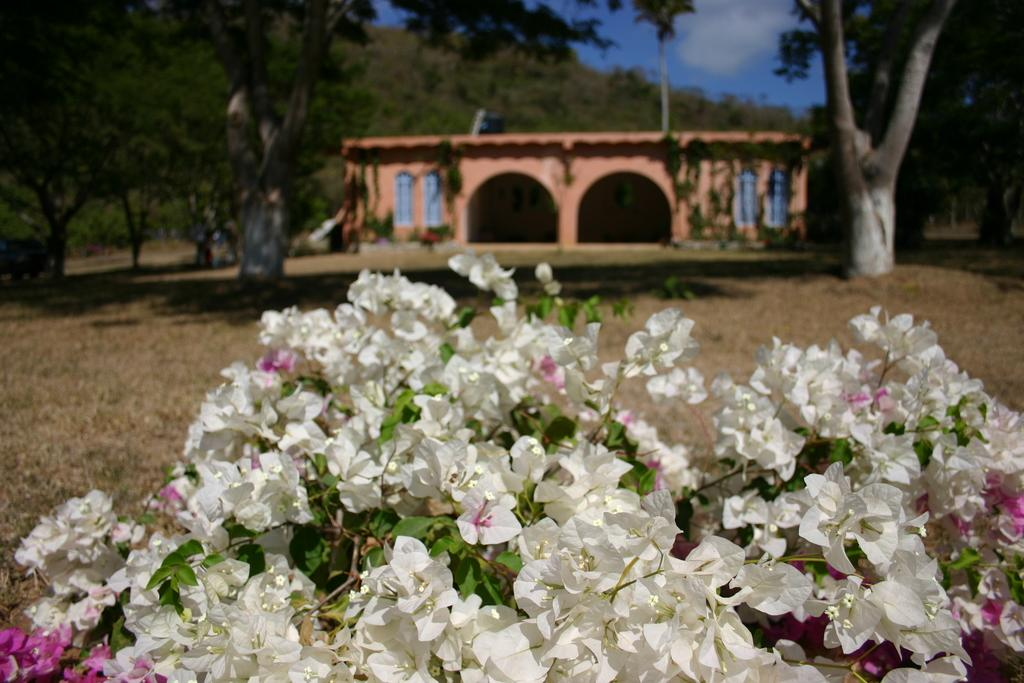What types of plants are in the foreground of the image? There are flowers and leaves in the foreground of the image. What structures can be seen in the background of the image? There is a house and trees in the background of the image. What type of cushion is being used for reading in the image? There is no cushion or reading activity present in the image. 